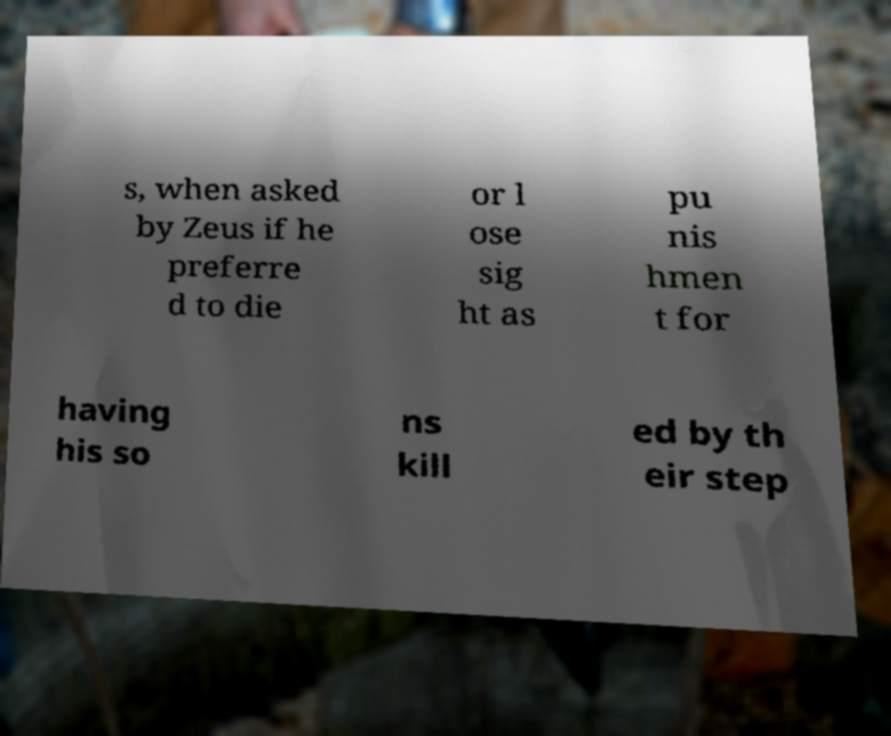Could you extract and type out the text from this image? s, when asked by Zeus if he preferre d to die or l ose sig ht as pu nis hmen t for having his so ns kill ed by th eir step 